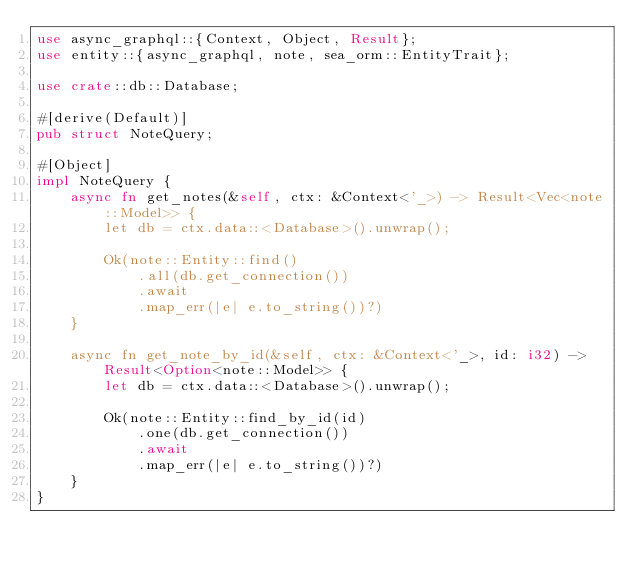<code> <loc_0><loc_0><loc_500><loc_500><_Rust_>use async_graphql::{Context, Object, Result};
use entity::{async_graphql, note, sea_orm::EntityTrait};

use crate::db::Database;

#[derive(Default)]
pub struct NoteQuery;

#[Object]
impl NoteQuery {
    async fn get_notes(&self, ctx: &Context<'_>) -> Result<Vec<note::Model>> {
        let db = ctx.data::<Database>().unwrap();

        Ok(note::Entity::find()
            .all(db.get_connection())
            .await
            .map_err(|e| e.to_string())?)
    }

    async fn get_note_by_id(&self, ctx: &Context<'_>, id: i32) -> Result<Option<note::Model>> {
        let db = ctx.data::<Database>().unwrap();

        Ok(note::Entity::find_by_id(id)
            .one(db.get_connection())
            .await
            .map_err(|e| e.to_string())?)
    }
}
</code> 